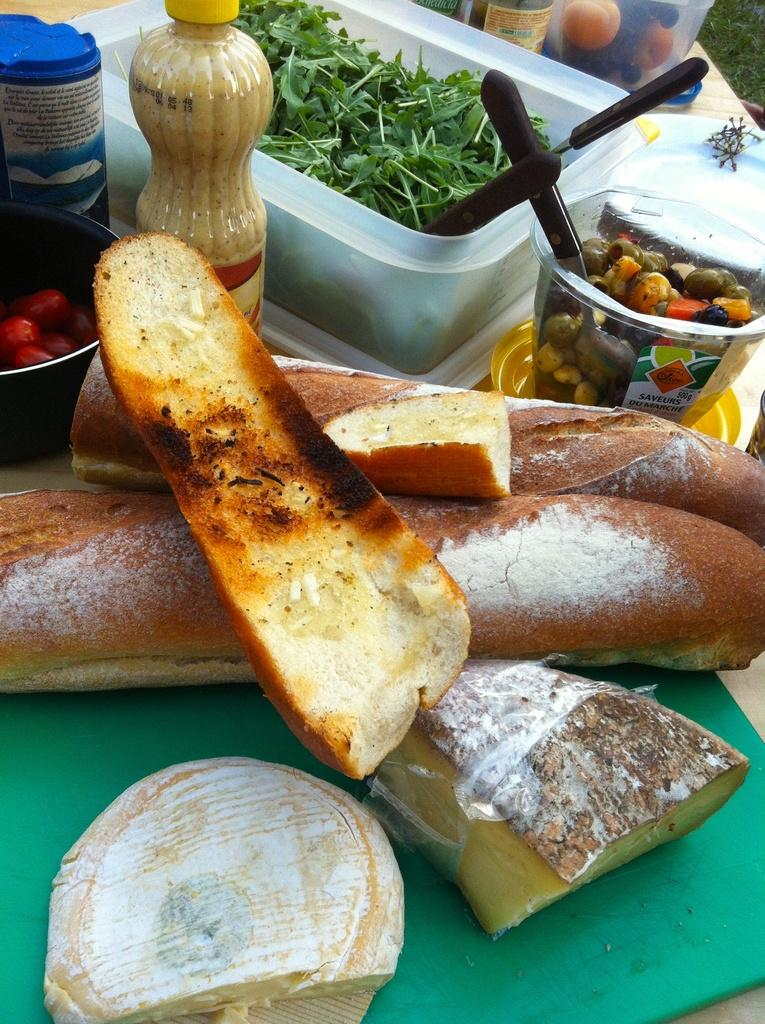What piece of furniture is present in the image? There is a table in the image. What type of food items can be seen on the table? There are breads on the table. What else is on the table besides food items? There are containers, knives, and bottles on the table. Who is the expert on the table in the image? There is no expert present on the table in the image. What unit of measurement is used to determine the size of the pot in the image? There is no pot present in the image, so no unit of measurement is needed to determine its size. 